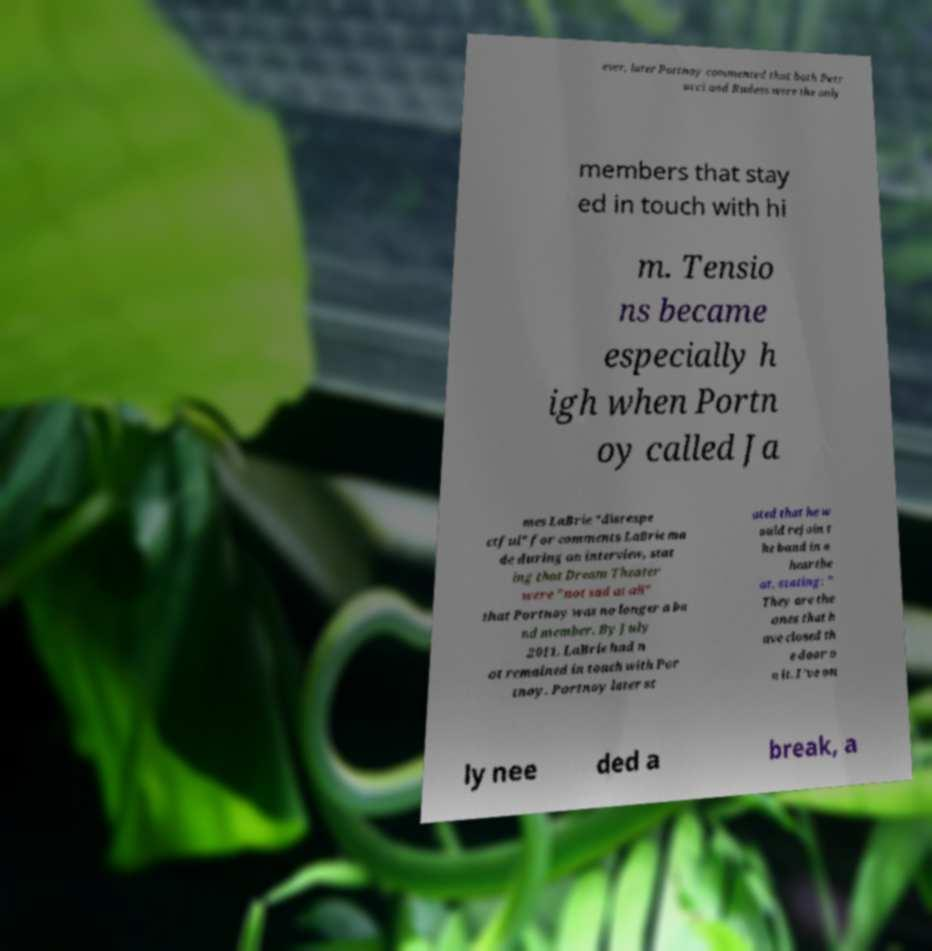Please read and relay the text visible in this image. What does it say? ever, later Portnoy commented that both Petr ucci and Rudess were the only members that stay ed in touch with hi m. Tensio ns became especially h igh when Portn oy called Ja mes LaBrie "disrespe ctful" for comments LaBrie ma de during an interview, stat ing that Dream Theater were "not sad at all" that Portnoy was no longer a ba nd member. By July 2011, LaBrie had n ot remained in touch with Por tnoy. Portnoy later st ated that he w ould rejoin t he band in a heartbe at, stating: " They are the ones that h ave closed th e door o n it. I've on ly nee ded a break, a 